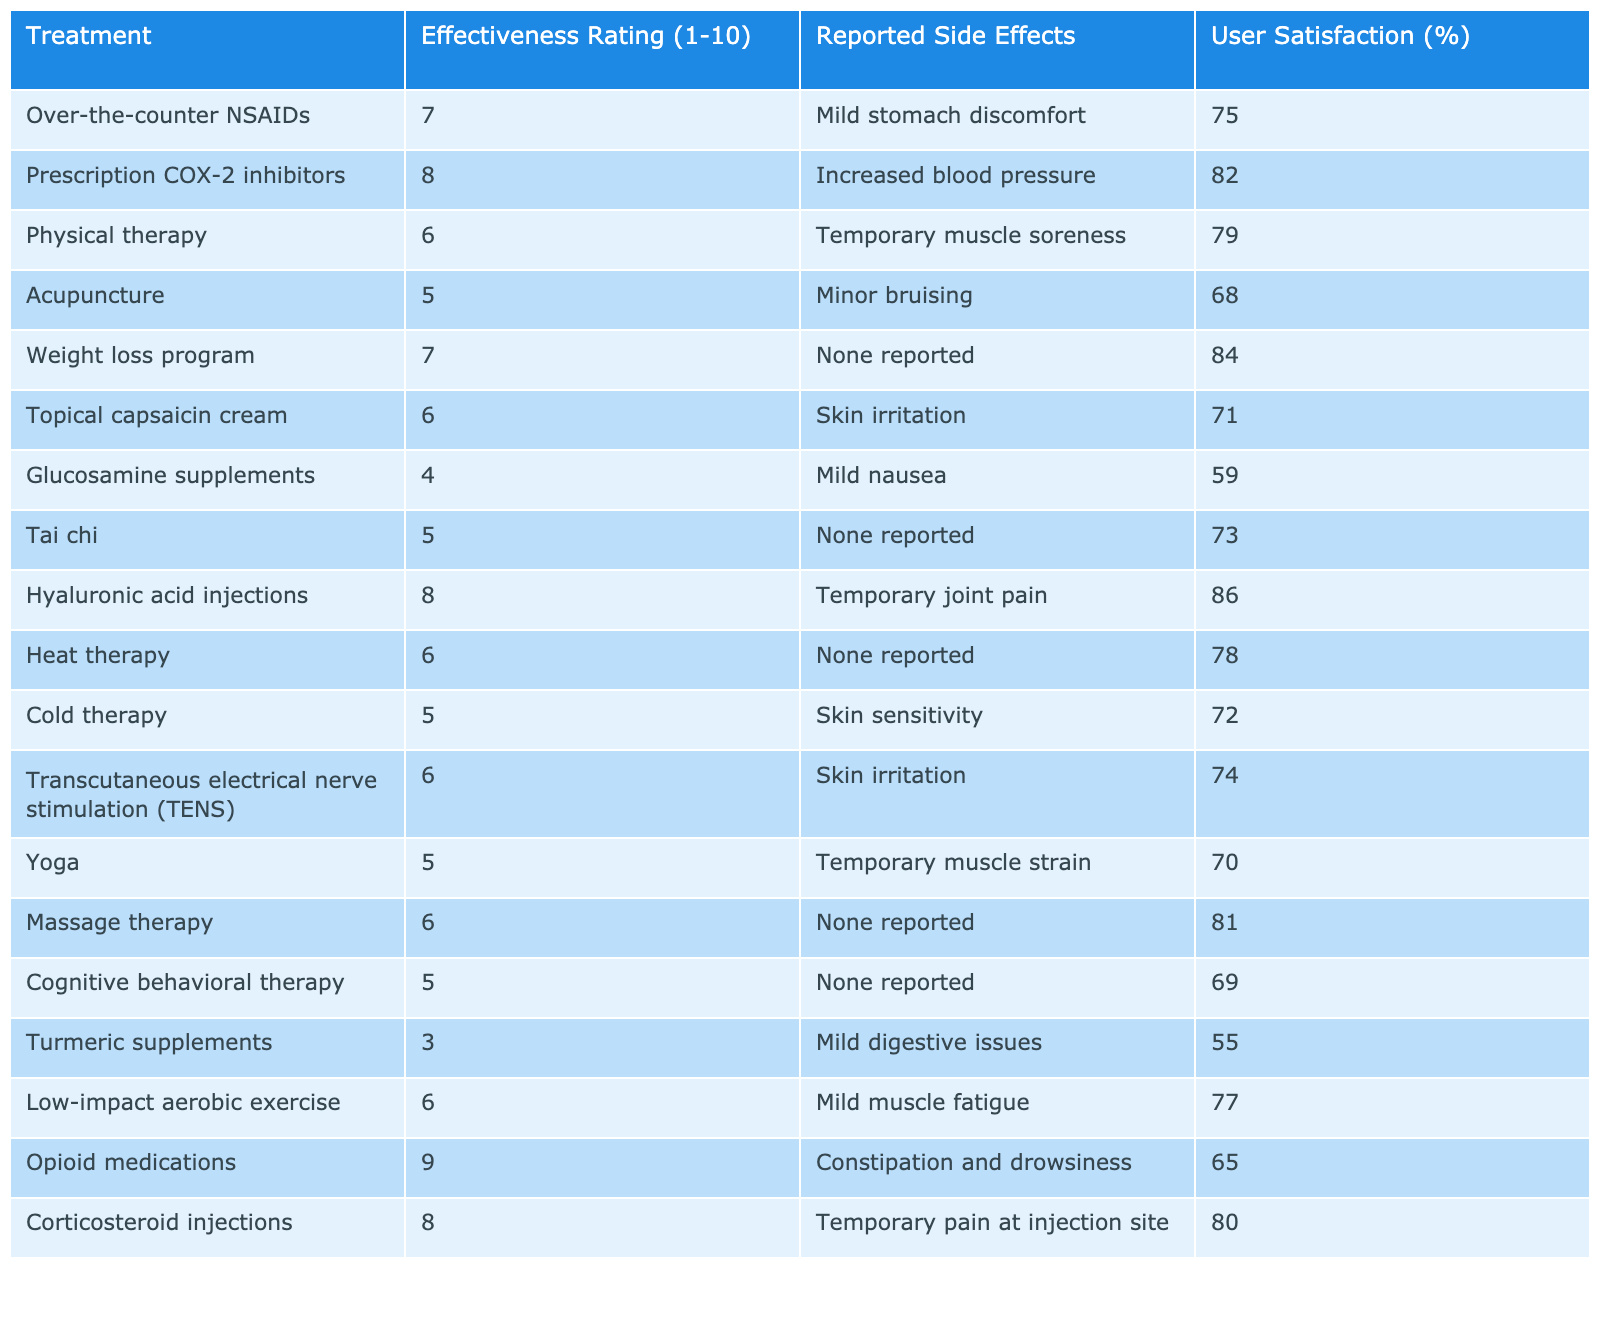What is the effectiveness rating of opioid medications? The table lists the effectiveness rating for each treatment. Looking for the row corresponding to opioid medications, we find the effectiveness rating is 9.
Answer: 9 Which pain management technique has the highest user satisfaction? By examining the user satisfaction percentage for each technique, we identify that hyaluronic acid injections have the highest at 86%.
Answer: 86% Is the effectiveness rating of acupuncture higher than that of glucosamine supplements? Acupuncture has an effectiveness rating of 5, while glucosamine supplements have a rating of 4. Since 5 is greater than 4, acupuncture's rating is higher.
Answer: Yes Calculate the average effectiveness rating of all treatments listed. First, we sum the effectiveness ratings: (7 + 8 + 6 + 5 + 7 + 6 + 4 + 5 + 8 + 6 + 5 + 6 + 5 + 5 + 3 + 6 + 9 + 8) = 101. There are 18 treatments, so the average rating is 101 divided by 18, which equals approximately 5.61.
Answer: Approximately 5.61 Which treatment has the least reported side effects? Looking closely at the reported side effects, the weight loss program has none reported. Thus, it is the treatment with the least side effects.
Answer: Weight loss program What is the effectiveness rating difference between prescription COX-2 inhibitors and hyaluronic acid injections? Prescription COX-2 inhibitors have an effectiveness rating of 8, while hyaluronic acid injections also have a rating of 8. The difference is 8 - 8 = 0, indicating no difference in their effectiveness.
Answer: 0 Are there any treatments with a user satisfaction rate above 80%? Observing the user satisfaction rates, we find that both hyaluronic acid injections (86%) and corticosteroid injections (80%) have satisfaction rates above 80%.
Answer: Yes How many treatments reported mild stomach discomfort as a side effect? By checking the reported side effects, we see that over-the-counter NSAIDs are the only treatment with mild stomach discomfort, indicating just one treatment has this side effect.
Answer: 1 Which treatment has a higher effectiveness rating, yoga or cold therapy? Yoga has an effectiveness rating of 5, while cold therapy also has a rating of 5. Since they have the same rating, neither is higher.
Answer: Same rating What percentage of users is satisfied with topical capsaicin cream? The user satisfaction percentage for topical capsaicin cream is directly listed in the table as 71%.
Answer: 71% 